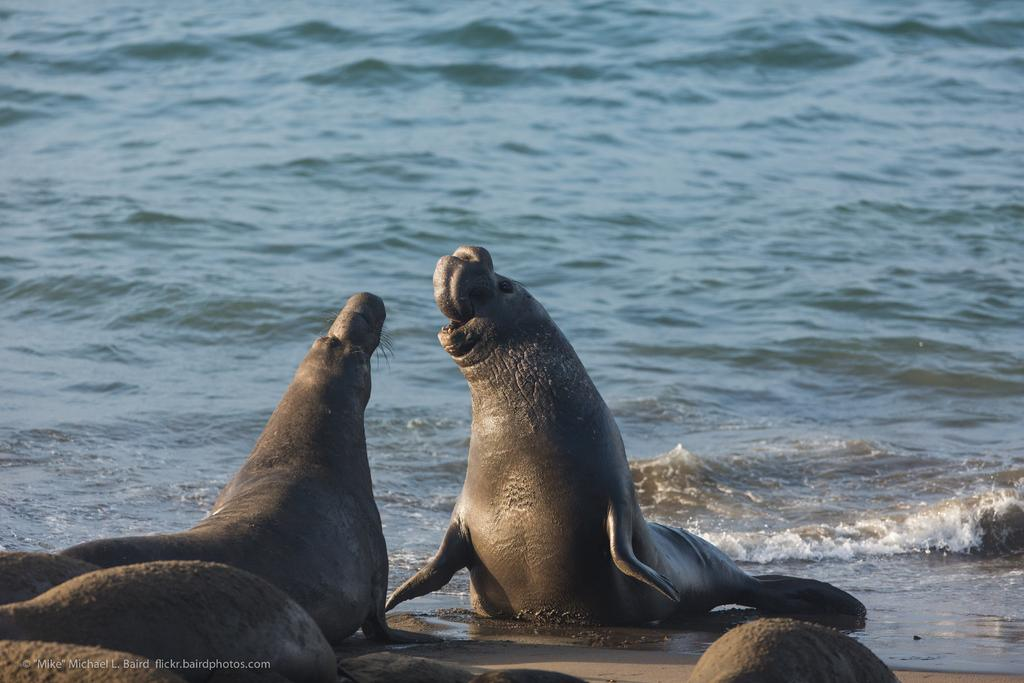What animals are present in the image? There are seals in the image. What is the primary element in which the seals are situated? There is water in the image, and the seals are in the water. Can you describe any additional features of the image? There is a watermark at the bottom left side of the image. What is the plot of the story being told by the seals in the image? There is no story being told by the seals in the image, as they are animals and not characters in a narrative. 